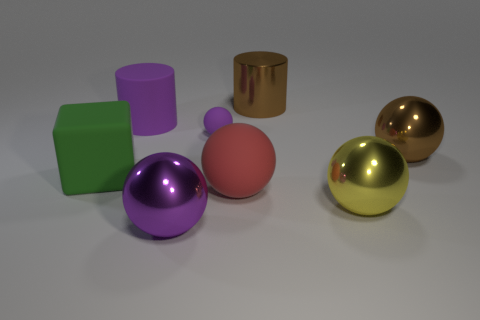Subtract all purple metal balls. How many balls are left? 4 Add 1 purple shiny cylinders. How many objects exist? 9 Subtract all purple cubes. How many purple balls are left? 2 Subtract all cubes. How many objects are left? 7 Subtract all yellow spheres. How many spheres are left? 4 Subtract 0 green balls. How many objects are left? 8 Subtract all green balls. Subtract all yellow cylinders. How many balls are left? 5 Subtract all big gray metal balls. Subtract all big matte cubes. How many objects are left? 7 Add 7 big metal spheres. How many big metal spheres are left? 10 Add 3 tiny brown metallic spheres. How many tiny brown metallic spheres exist? 3 